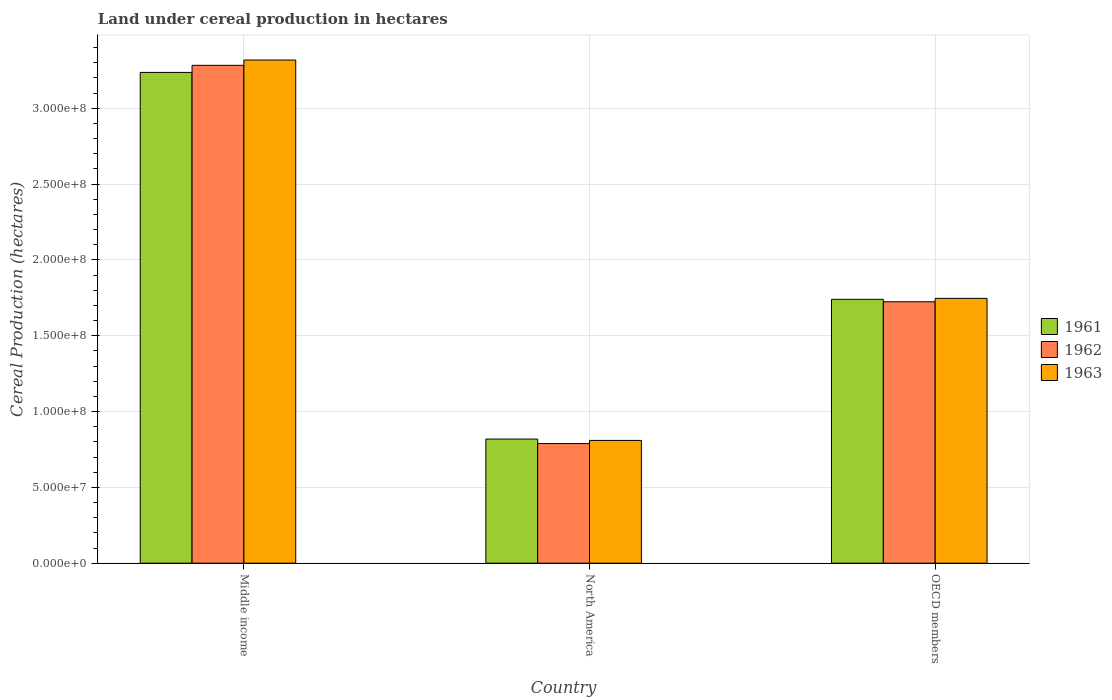How many different coloured bars are there?
Your answer should be very brief. 3. Are the number of bars per tick equal to the number of legend labels?
Make the answer very short. Yes. Are the number of bars on each tick of the X-axis equal?
Give a very brief answer. Yes. What is the land under cereal production in 1961 in Middle income?
Give a very brief answer. 3.24e+08. Across all countries, what is the maximum land under cereal production in 1963?
Ensure brevity in your answer.  3.32e+08. Across all countries, what is the minimum land under cereal production in 1963?
Ensure brevity in your answer.  8.10e+07. What is the total land under cereal production in 1962 in the graph?
Provide a succinct answer. 5.80e+08. What is the difference between the land under cereal production in 1961 in Middle income and that in OECD members?
Provide a succinct answer. 1.50e+08. What is the difference between the land under cereal production in 1963 in OECD members and the land under cereal production in 1962 in North America?
Your response must be concise. 9.58e+07. What is the average land under cereal production in 1962 per country?
Ensure brevity in your answer.  1.93e+08. What is the difference between the land under cereal production of/in 1962 and land under cereal production of/in 1961 in Middle income?
Your answer should be very brief. 4.68e+06. What is the ratio of the land under cereal production in 1961 in North America to that in OECD members?
Provide a short and direct response. 0.47. Is the difference between the land under cereal production in 1962 in Middle income and North America greater than the difference between the land under cereal production in 1961 in Middle income and North America?
Provide a short and direct response. Yes. What is the difference between the highest and the second highest land under cereal production in 1962?
Offer a very short reply. 2.49e+08. What is the difference between the highest and the lowest land under cereal production in 1961?
Provide a succinct answer. 2.42e+08. What does the 3rd bar from the right in Middle income represents?
Ensure brevity in your answer.  1961. What is the difference between two consecutive major ticks on the Y-axis?
Your answer should be compact. 5.00e+07. Are the values on the major ticks of Y-axis written in scientific E-notation?
Your answer should be compact. Yes. Where does the legend appear in the graph?
Give a very brief answer. Center right. What is the title of the graph?
Ensure brevity in your answer.  Land under cereal production in hectares. Does "1988" appear as one of the legend labels in the graph?
Make the answer very short. No. What is the label or title of the Y-axis?
Give a very brief answer. Cereal Production (hectares). What is the Cereal Production (hectares) in 1961 in Middle income?
Make the answer very short. 3.24e+08. What is the Cereal Production (hectares) of 1962 in Middle income?
Offer a terse response. 3.28e+08. What is the Cereal Production (hectares) of 1963 in Middle income?
Provide a succinct answer. 3.32e+08. What is the Cereal Production (hectares) in 1961 in North America?
Provide a succinct answer. 8.19e+07. What is the Cereal Production (hectares) of 1962 in North America?
Keep it short and to the point. 7.89e+07. What is the Cereal Production (hectares) in 1963 in North America?
Give a very brief answer. 8.10e+07. What is the Cereal Production (hectares) of 1961 in OECD members?
Give a very brief answer. 1.74e+08. What is the Cereal Production (hectares) in 1962 in OECD members?
Offer a terse response. 1.72e+08. What is the Cereal Production (hectares) of 1963 in OECD members?
Make the answer very short. 1.75e+08. Across all countries, what is the maximum Cereal Production (hectares) of 1961?
Your answer should be very brief. 3.24e+08. Across all countries, what is the maximum Cereal Production (hectares) in 1962?
Keep it short and to the point. 3.28e+08. Across all countries, what is the maximum Cereal Production (hectares) in 1963?
Offer a very short reply. 3.32e+08. Across all countries, what is the minimum Cereal Production (hectares) in 1961?
Make the answer very short. 8.19e+07. Across all countries, what is the minimum Cereal Production (hectares) of 1962?
Your response must be concise. 7.89e+07. Across all countries, what is the minimum Cereal Production (hectares) in 1963?
Your answer should be very brief. 8.10e+07. What is the total Cereal Production (hectares) in 1961 in the graph?
Your answer should be very brief. 5.80e+08. What is the total Cereal Production (hectares) of 1962 in the graph?
Your answer should be very brief. 5.80e+08. What is the total Cereal Production (hectares) in 1963 in the graph?
Your response must be concise. 5.87e+08. What is the difference between the Cereal Production (hectares) in 1961 in Middle income and that in North America?
Keep it short and to the point. 2.42e+08. What is the difference between the Cereal Production (hectares) of 1962 in Middle income and that in North America?
Your response must be concise. 2.49e+08. What is the difference between the Cereal Production (hectares) of 1963 in Middle income and that in North America?
Offer a terse response. 2.51e+08. What is the difference between the Cereal Production (hectares) in 1961 in Middle income and that in OECD members?
Make the answer very short. 1.50e+08. What is the difference between the Cereal Production (hectares) in 1962 in Middle income and that in OECD members?
Provide a succinct answer. 1.56e+08. What is the difference between the Cereal Production (hectares) of 1963 in Middle income and that in OECD members?
Ensure brevity in your answer.  1.57e+08. What is the difference between the Cereal Production (hectares) in 1961 in North America and that in OECD members?
Offer a terse response. -9.22e+07. What is the difference between the Cereal Production (hectares) of 1962 in North America and that in OECD members?
Provide a succinct answer. -9.35e+07. What is the difference between the Cereal Production (hectares) in 1963 in North America and that in OECD members?
Give a very brief answer. -9.37e+07. What is the difference between the Cereal Production (hectares) of 1961 in Middle income and the Cereal Production (hectares) of 1962 in North America?
Make the answer very short. 2.45e+08. What is the difference between the Cereal Production (hectares) of 1961 in Middle income and the Cereal Production (hectares) of 1963 in North America?
Ensure brevity in your answer.  2.43e+08. What is the difference between the Cereal Production (hectares) in 1962 in Middle income and the Cereal Production (hectares) in 1963 in North America?
Offer a terse response. 2.47e+08. What is the difference between the Cereal Production (hectares) of 1961 in Middle income and the Cereal Production (hectares) of 1962 in OECD members?
Provide a short and direct response. 1.51e+08. What is the difference between the Cereal Production (hectares) in 1961 in Middle income and the Cereal Production (hectares) in 1963 in OECD members?
Give a very brief answer. 1.49e+08. What is the difference between the Cereal Production (hectares) of 1962 in Middle income and the Cereal Production (hectares) of 1963 in OECD members?
Your answer should be compact. 1.54e+08. What is the difference between the Cereal Production (hectares) of 1961 in North America and the Cereal Production (hectares) of 1962 in OECD members?
Keep it short and to the point. -9.06e+07. What is the difference between the Cereal Production (hectares) of 1961 in North America and the Cereal Production (hectares) of 1963 in OECD members?
Ensure brevity in your answer.  -9.28e+07. What is the difference between the Cereal Production (hectares) of 1962 in North America and the Cereal Production (hectares) of 1963 in OECD members?
Give a very brief answer. -9.58e+07. What is the average Cereal Production (hectares) in 1961 per country?
Offer a very short reply. 1.93e+08. What is the average Cereal Production (hectares) of 1962 per country?
Offer a terse response. 1.93e+08. What is the average Cereal Production (hectares) in 1963 per country?
Provide a succinct answer. 1.96e+08. What is the difference between the Cereal Production (hectares) in 1961 and Cereal Production (hectares) in 1962 in Middle income?
Give a very brief answer. -4.68e+06. What is the difference between the Cereal Production (hectares) of 1961 and Cereal Production (hectares) of 1963 in Middle income?
Your answer should be compact. -8.16e+06. What is the difference between the Cereal Production (hectares) in 1962 and Cereal Production (hectares) in 1963 in Middle income?
Keep it short and to the point. -3.48e+06. What is the difference between the Cereal Production (hectares) in 1961 and Cereal Production (hectares) in 1962 in North America?
Keep it short and to the point. 2.97e+06. What is the difference between the Cereal Production (hectares) in 1961 and Cereal Production (hectares) in 1963 in North America?
Your answer should be compact. 8.78e+05. What is the difference between the Cereal Production (hectares) of 1962 and Cereal Production (hectares) of 1963 in North America?
Offer a very short reply. -2.09e+06. What is the difference between the Cereal Production (hectares) of 1961 and Cereal Production (hectares) of 1962 in OECD members?
Your response must be concise. 1.62e+06. What is the difference between the Cereal Production (hectares) of 1961 and Cereal Production (hectares) of 1963 in OECD members?
Offer a terse response. -6.28e+05. What is the difference between the Cereal Production (hectares) in 1962 and Cereal Production (hectares) in 1963 in OECD members?
Provide a succinct answer. -2.25e+06. What is the ratio of the Cereal Production (hectares) in 1961 in Middle income to that in North America?
Give a very brief answer. 3.95. What is the ratio of the Cereal Production (hectares) of 1962 in Middle income to that in North America?
Keep it short and to the point. 4.16. What is the ratio of the Cereal Production (hectares) in 1963 in Middle income to that in North America?
Your answer should be very brief. 4.1. What is the ratio of the Cereal Production (hectares) of 1961 in Middle income to that in OECD members?
Ensure brevity in your answer.  1.86. What is the ratio of the Cereal Production (hectares) in 1962 in Middle income to that in OECD members?
Provide a succinct answer. 1.9. What is the ratio of the Cereal Production (hectares) in 1963 in Middle income to that in OECD members?
Your answer should be compact. 1.9. What is the ratio of the Cereal Production (hectares) in 1961 in North America to that in OECD members?
Your response must be concise. 0.47. What is the ratio of the Cereal Production (hectares) in 1962 in North America to that in OECD members?
Offer a terse response. 0.46. What is the ratio of the Cereal Production (hectares) of 1963 in North America to that in OECD members?
Ensure brevity in your answer.  0.46. What is the difference between the highest and the second highest Cereal Production (hectares) in 1961?
Ensure brevity in your answer.  1.50e+08. What is the difference between the highest and the second highest Cereal Production (hectares) in 1962?
Keep it short and to the point. 1.56e+08. What is the difference between the highest and the second highest Cereal Production (hectares) in 1963?
Keep it short and to the point. 1.57e+08. What is the difference between the highest and the lowest Cereal Production (hectares) in 1961?
Make the answer very short. 2.42e+08. What is the difference between the highest and the lowest Cereal Production (hectares) in 1962?
Offer a very short reply. 2.49e+08. What is the difference between the highest and the lowest Cereal Production (hectares) in 1963?
Make the answer very short. 2.51e+08. 